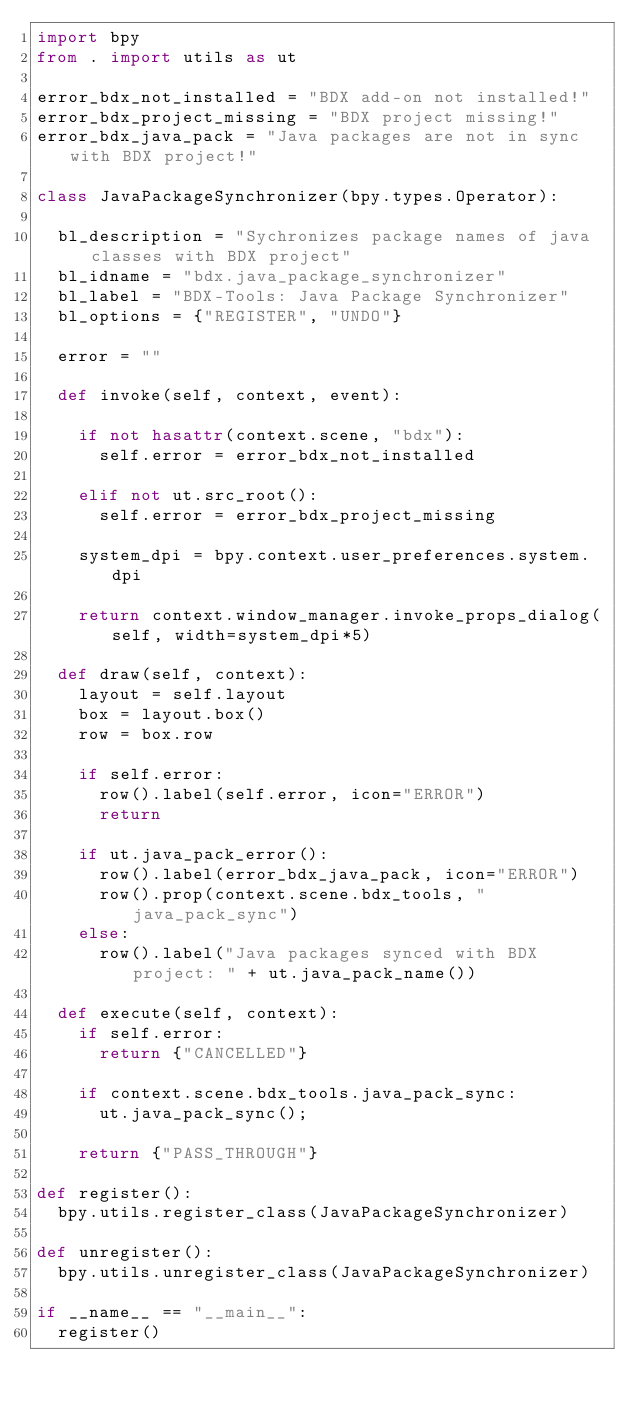Convert code to text. <code><loc_0><loc_0><loc_500><loc_500><_Python_>import bpy
from . import utils as ut

error_bdx_not_installed = "BDX add-on not installed!"
error_bdx_project_missing = "BDX project missing!"
error_bdx_java_pack = "Java packages are not in sync with BDX project!"

class JavaPackageSynchronizer(bpy.types.Operator):
	
	bl_description = "Sychronizes package names of java classes with BDX project"
	bl_idname = "bdx.java_package_synchronizer"
	bl_label = "BDX-Tools: Java Package Synchronizer"
	bl_options = {"REGISTER", "UNDO"}
	
	error = ""
	
	def invoke(self, context, event):
		
		if not hasattr(context.scene, "bdx"):
			self.error = error_bdx_not_installed
			
		elif not ut.src_root():
			self.error = error_bdx_project_missing
			
		system_dpi = bpy.context.user_preferences.system.dpi
		
		return context.window_manager.invoke_props_dialog(self, width=system_dpi*5)
		
	def draw(self, context):
		layout = self.layout
		box = layout.box()
		row = box.row
		
		if self.error:
			row().label(self.error, icon="ERROR")
			return
			
		if ut.java_pack_error():
			row().label(error_bdx_java_pack, icon="ERROR")
			row().prop(context.scene.bdx_tools, "java_pack_sync")
		else:
			row().label("Java packages synced with BDX project: " + ut.java_pack_name())
			
	def execute(self, context):
		if self.error:
			return {"CANCELLED"}
			
		if context.scene.bdx_tools.java_pack_sync:
			ut.java_pack_sync();
			
		return {"PASS_THROUGH"}
		
def register():
	bpy.utils.register_class(JavaPackageSynchronizer)
	
def unregister():
	bpy.utils.unregister_class(JavaPackageSynchronizer)
	
if __name__ == "__main__":
	register()
	</code> 